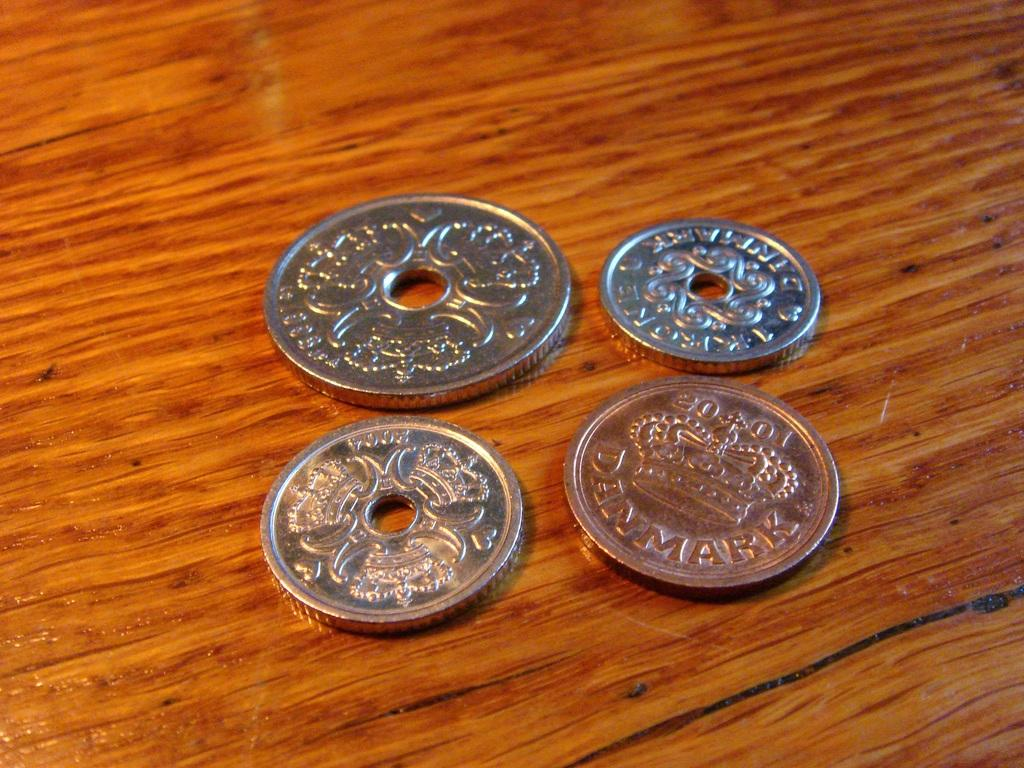What objects are present in the image? There are four coins in the image. Can you describe the surface on which the coins are placed? The coins are on a wooden surface. What feature is present on some of the coins? There are holes in the center of 3 of the coins. What type of ring can be seen on the coins in the image? There is no ring present on the coins in the image. What trick is being performed with the coins in the image? There is no trick being performed with the coins in the image; they are simply placed on the wooden surface. Is there a notebook visible in the image? There is no notebook present in the image. 